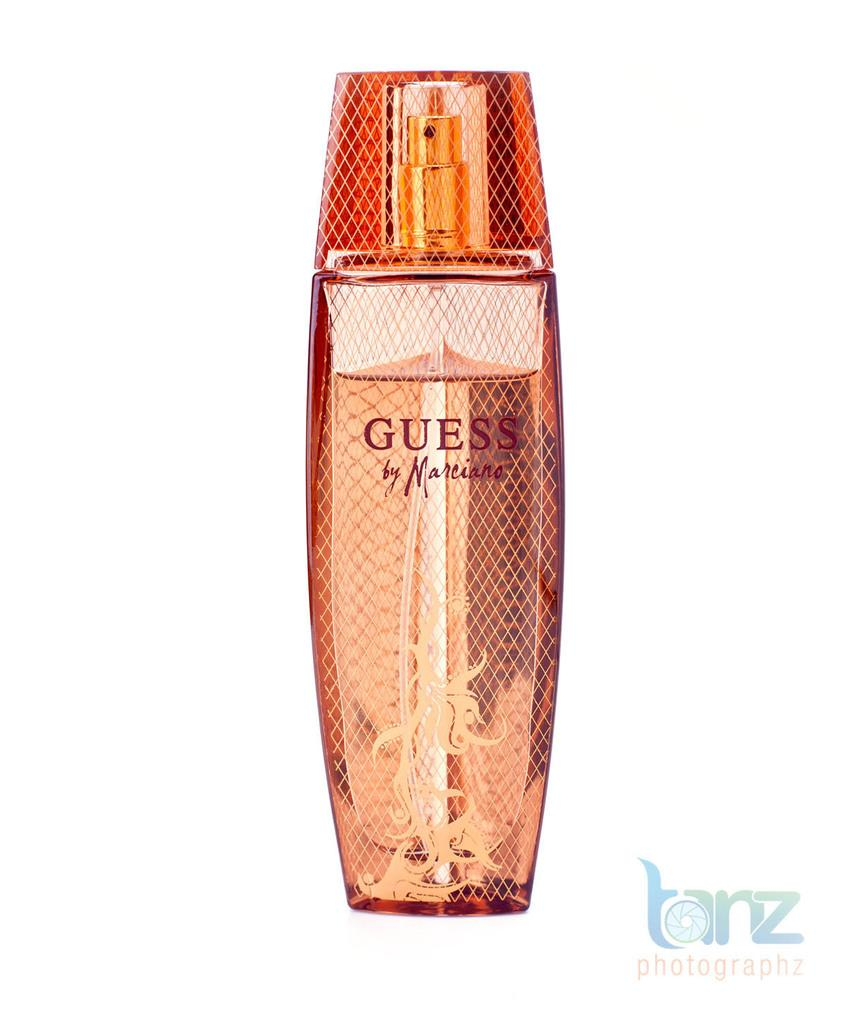<image>
Summarize the visual content of the image. An orange bottle of fragrance by the brand Guess 